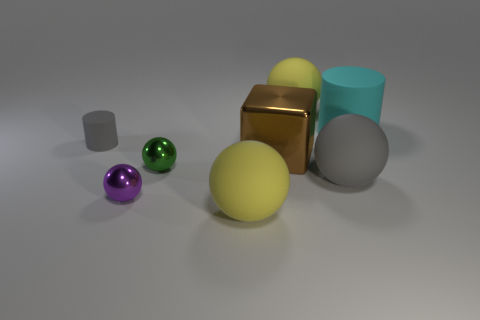Subtract all yellow spheres. How many spheres are left? 3 Subtract all tiny green balls. How many balls are left? 4 Subtract all brown balls. Subtract all red cubes. How many balls are left? 5 Add 1 purple objects. How many objects exist? 9 Subtract all cubes. How many objects are left? 7 Subtract 0 red cylinders. How many objects are left? 8 Subtract all gray cylinders. Subtract all small red balls. How many objects are left? 7 Add 5 small cylinders. How many small cylinders are left? 6 Add 8 large yellow rubber spheres. How many large yellow rubber spheres exist? 10 